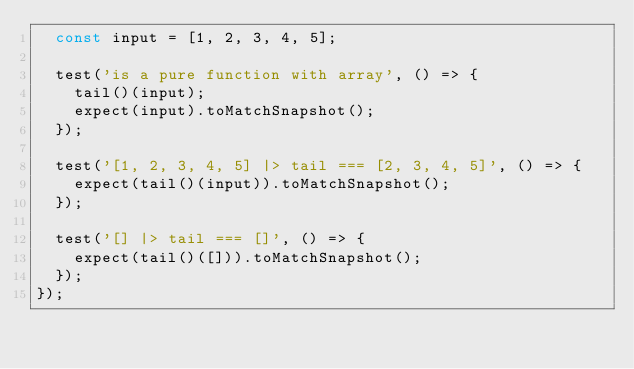Convert code to text. <code><loc_0><loc_0><loc_500><loc_500><_TypeScript_>  const input = [1, 2, 3, 4, 5];

  test('is a pure function with array', () => {
    tail()(input);
    expect(input).toMatchSnapshot();
  });

  test('[1, 2, 3, 4, 5] |> tail === [2, 3, 4, 5]', () => {
    expect(tail()(input)).toMatchSnapshot();
  });

  test('[] |> tail === []', () => {
    expect(tail()([])).toMatchSnapshot();
  });
});
</code> 